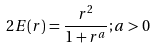Convert formula to latex. <formula><loc_0><loc_0><loc_500><loc_500>2 E ( r ) = \frac { r ^ { 2 } } { 1 + r ^ { a } } ; a > 0</formula> 